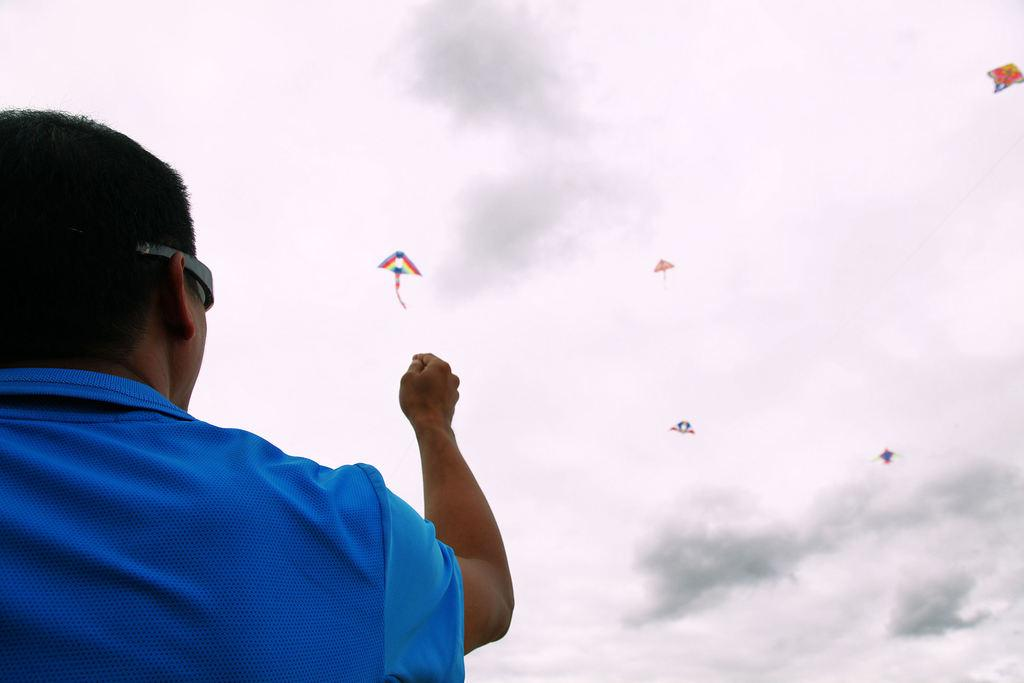Who or what is on the left side of the image? There is a person on the left side of the image. What can be seen in the middle of the image? There are kites in the middle of the image. What is visible in the image besides the person and kites? The sky is visible in the image. Can you tell me how many knives are being used to touch the kites in the image? There are no knives present in the image, and the kites are not being touched. 